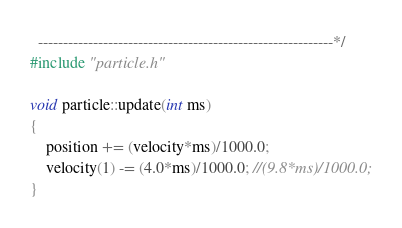<code> <loc_0><loc_0><loc_500><loc_500><_C++_>  -----------------------------------------------------------*/
#include "particle.h"

void particle::update(int ms)
{
	position += (velocity*ms)/1000.0;
	velocity(1) -= (4.0*ms)/1000.0; //(9.8*ms)/1000.0;
}
</code> 